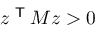<formula> <loc_0><loc_0><loc_500><loc_500>z ^ { T } M z > 0</formula> 